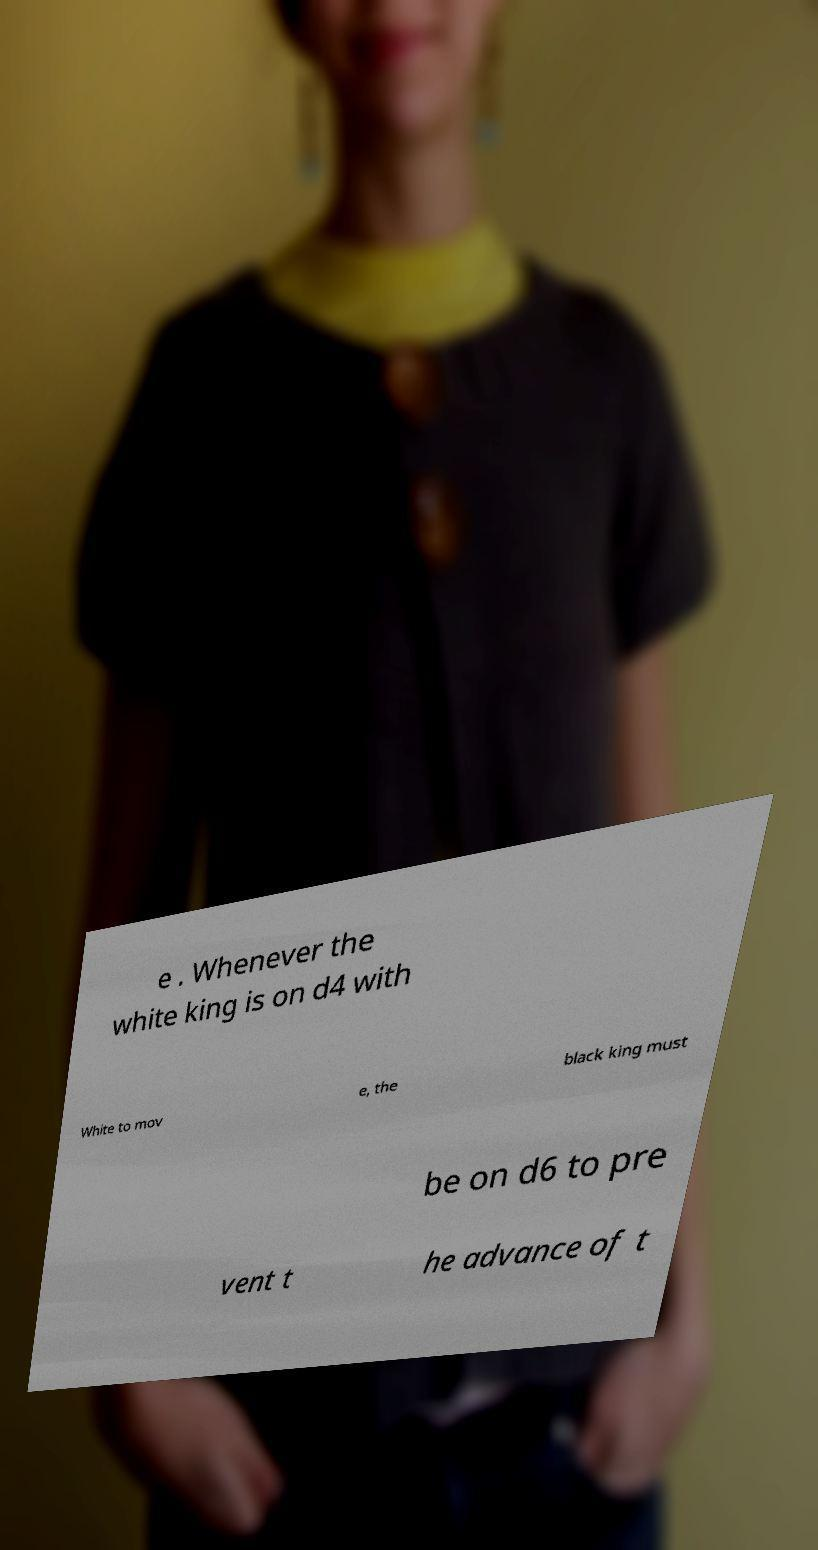Can you accurately transcribe the text from the provided image for me? e . Whenever the white king is on d4 with White to mov e, the black king must be on d6 to pre vent t he advance of t 